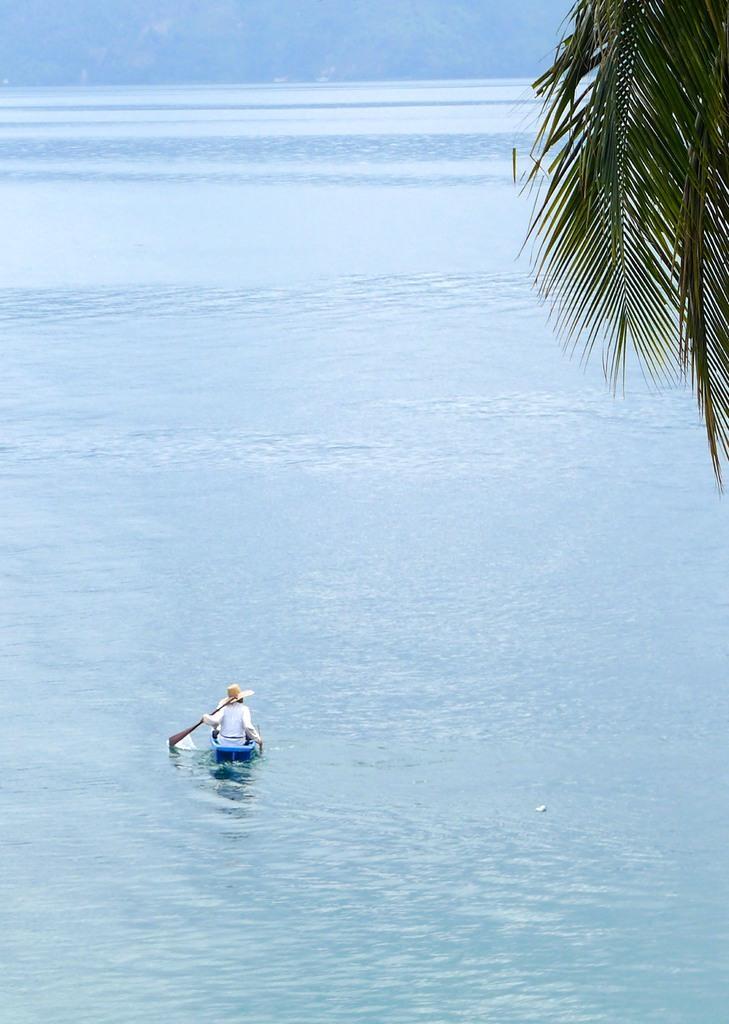How would you summarize this image in a sentence or two? In this image I can see a person is sitting in the boat and holding a paddle. The boat is on the water. I can see a tree. 